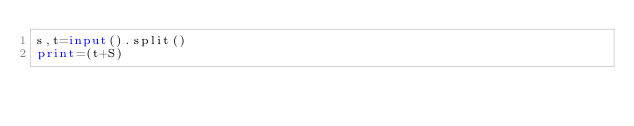Convert code to text. <code><loc_0><loc_0><loc_500><loc_500><_Python_>s,t=input().split()
print=(t+S)</code> 